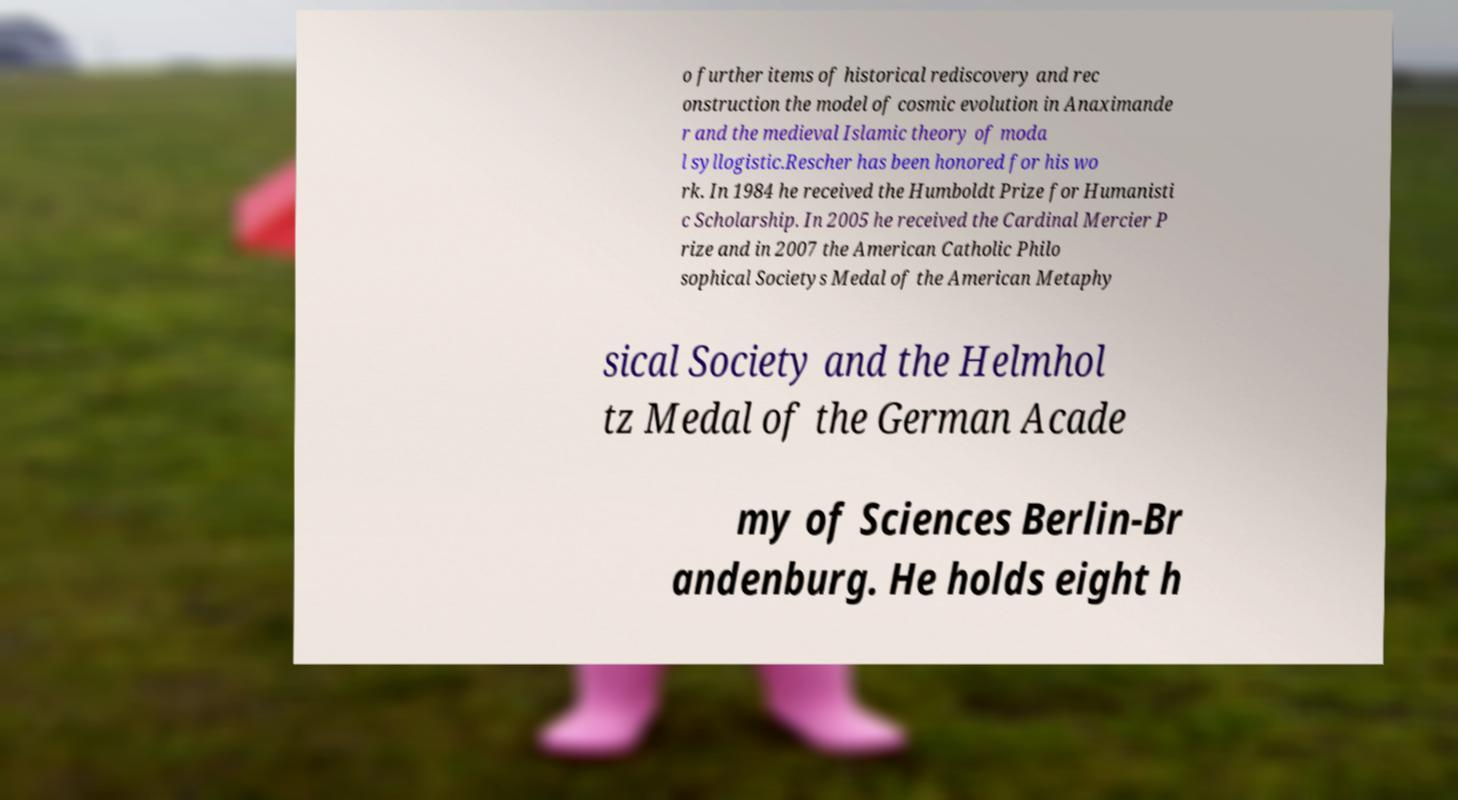There's text embedded in this image that I need extracted. Can you transcribe it verbatim? o further items of historical rediscovery and rec onstruction the model of cosmic evolution in Anaximande r and the medieval Islamic theory of moda l syllogistic.Rescher has been honored for his wo rk. In 1984 he received the Humboldt Prize for Humanisti c Scholarship. In 2005 he received the Cardinal Mercier P rize and in 2007 the American Catholic Philo sophical Societys Medal of the American Metaphy sical Society and the Helmhol tz Medal of the German Acade my of Sciences Berlin-Br andenburg. He holds eight h 